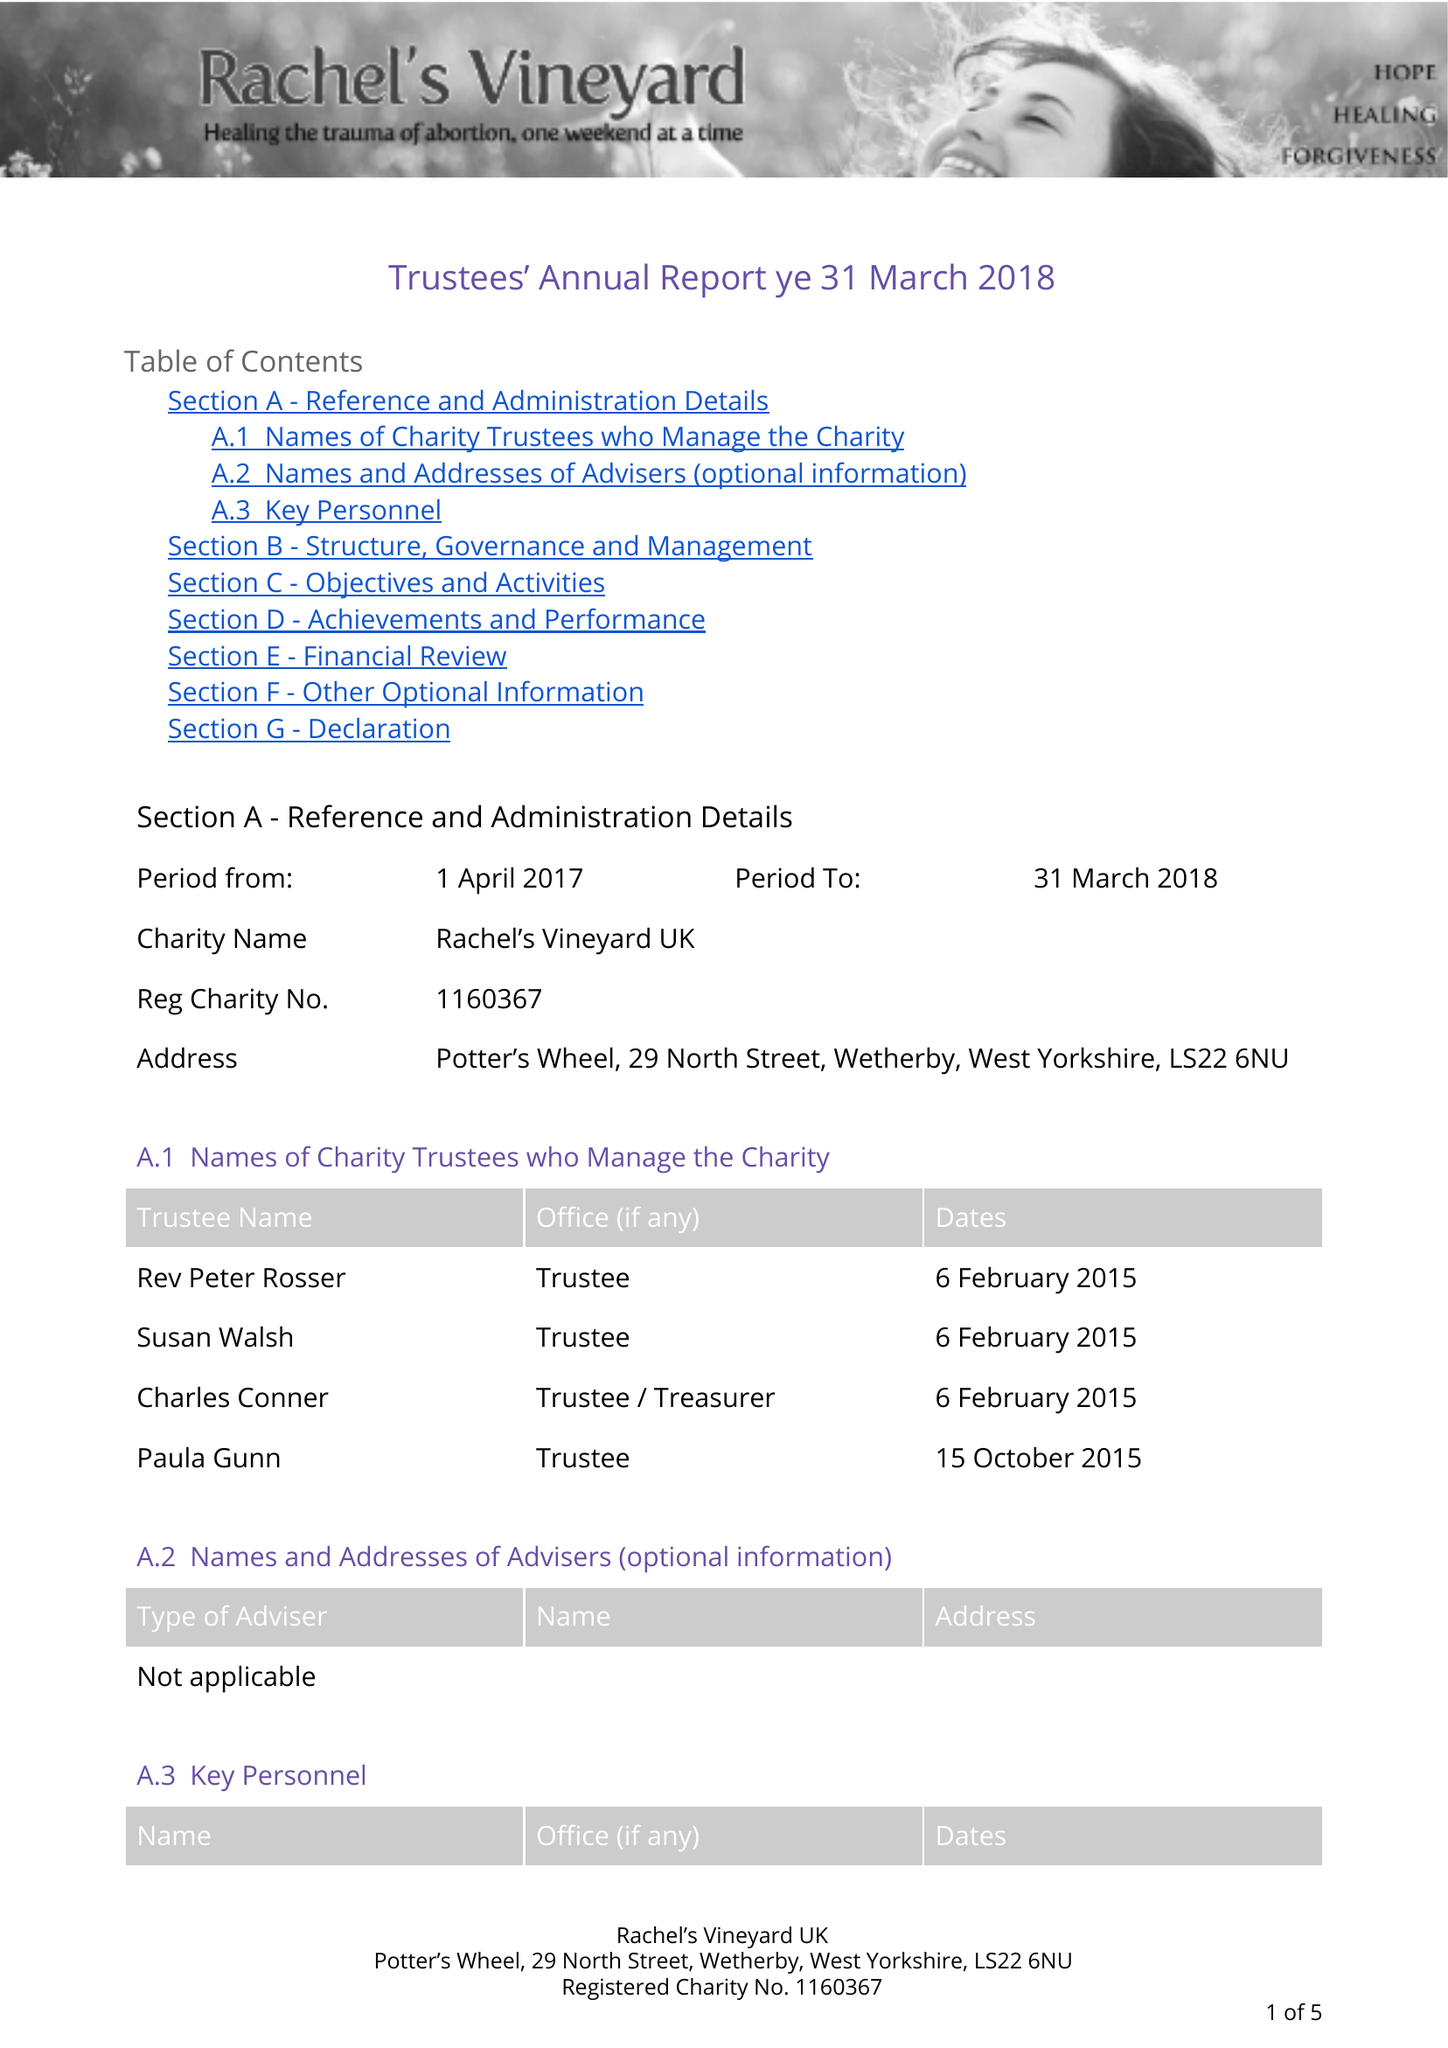What is the value for the report_date?
Answer the question using a single word or phrase. 2018-03-31 